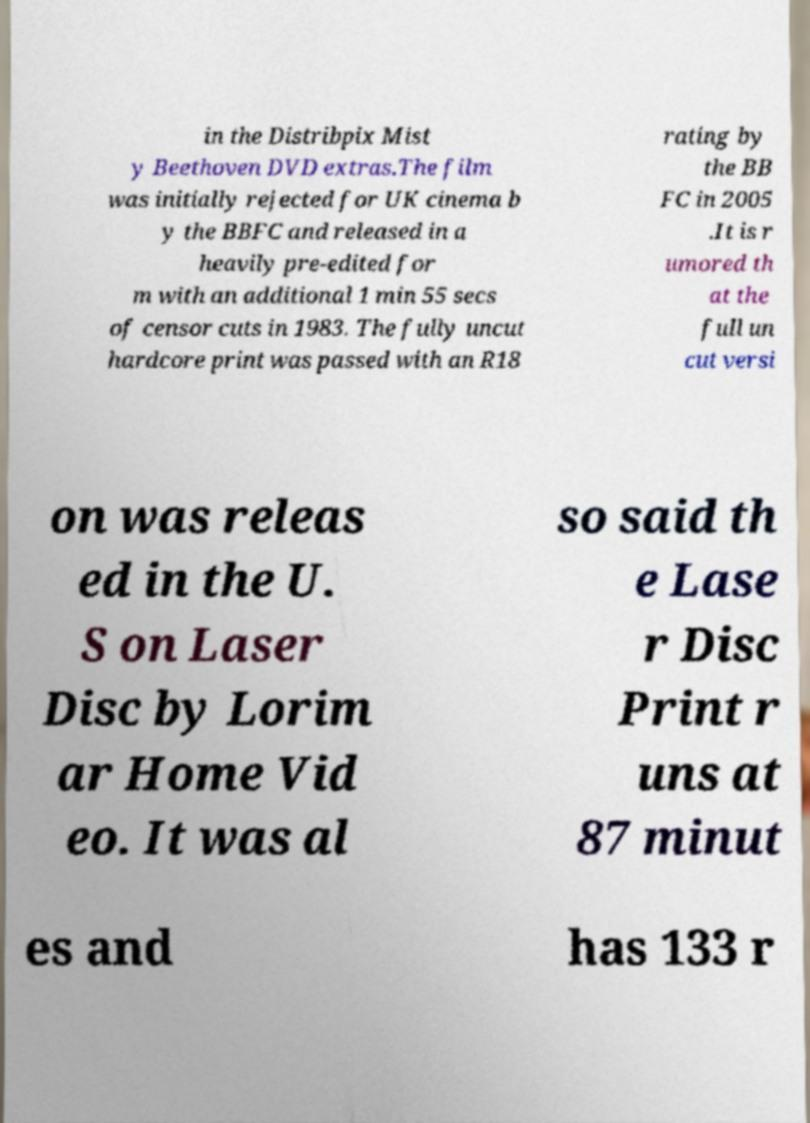For documentation purposes, I need the text within this image transcribed. Could you provide that? in the Distribpix Mist y Beethoven DVD extras.The film was initially rejected for UK cinema b y the BBFC and released in a heavily pre-edited for m with an additional 1 min 55 secs of censor cuts in 1983. The fully uncut hardcore print was passed with an R18 rating by the BB FC in 2005 .It is r umored th at the full un cut versi on was releas ed in the U. S on Laser Disc by Lorim ar Home Vid eo. It was al so said th e Lase r Disc Print r uns at 87 minut es and has 133 r 